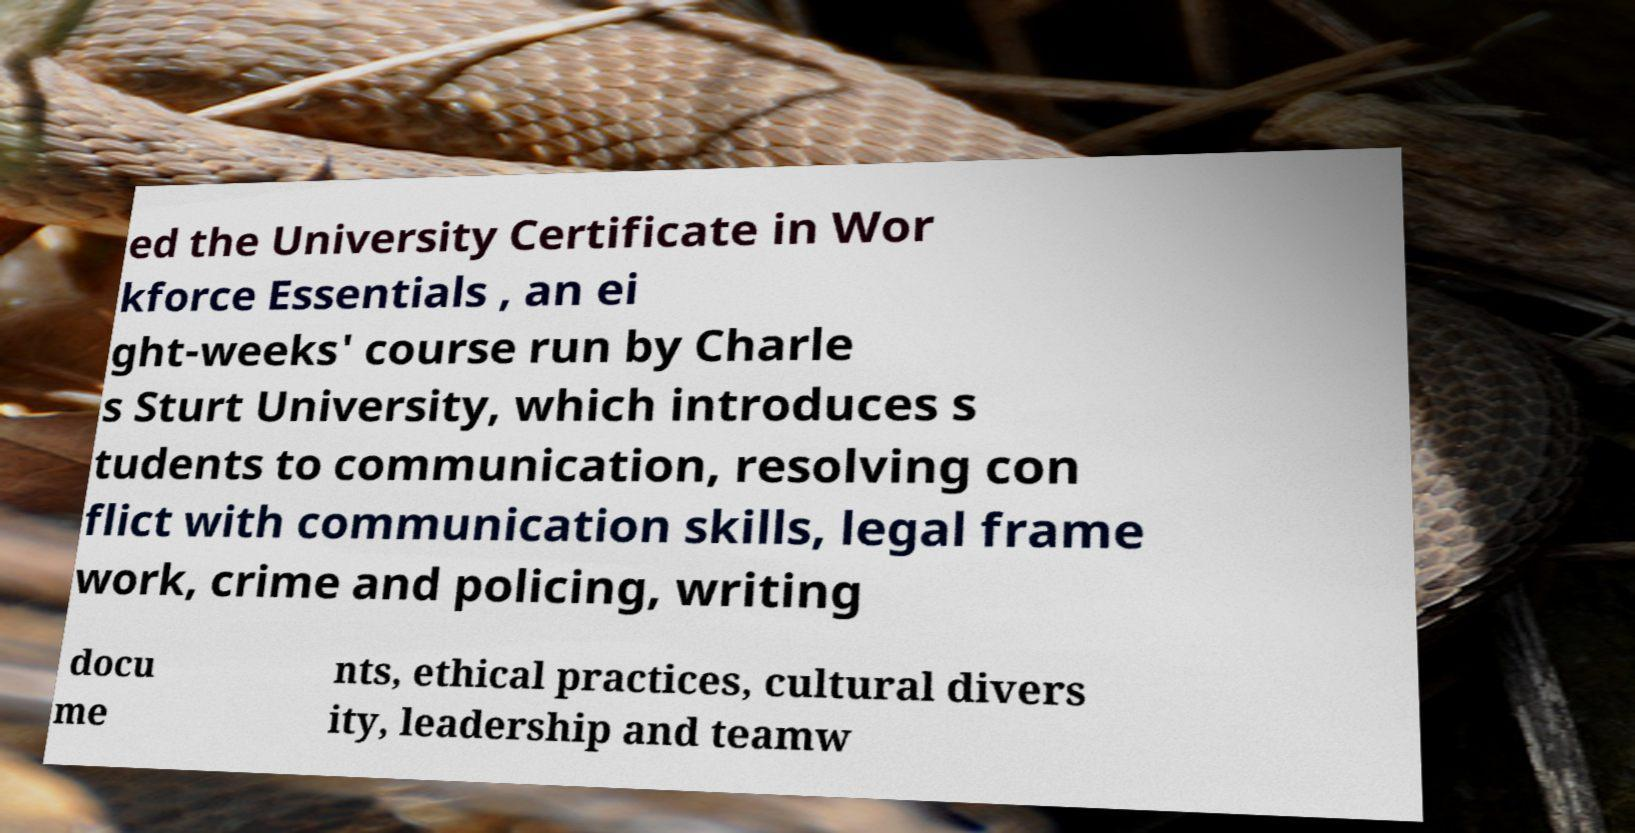Please identify and transcribe the text found in this image. ed the University Certificate in Wor kforce Essentials , an ei ght-weeks' course run by Charle s Sturt University, which introduces s tudents to communication, resolving con flict with communication skills, legal frame work, crime and policing, writing docu me nts, ethical practices, cultural divers ity, leadership and teamw 